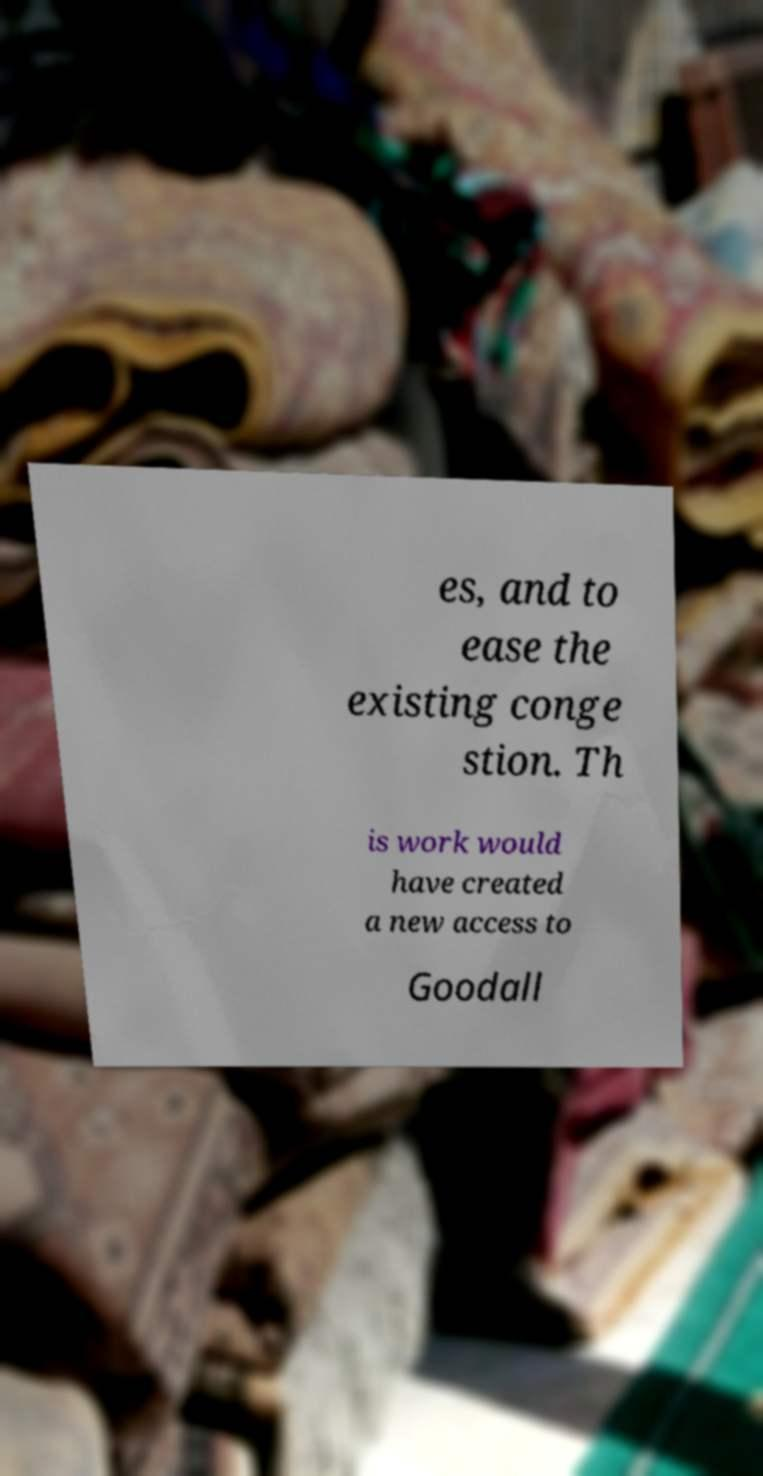I need the written content from this picture converted into text. Can you do that? es, and to ease the existing conge stion. Th is work would have created a new access to Goodall 